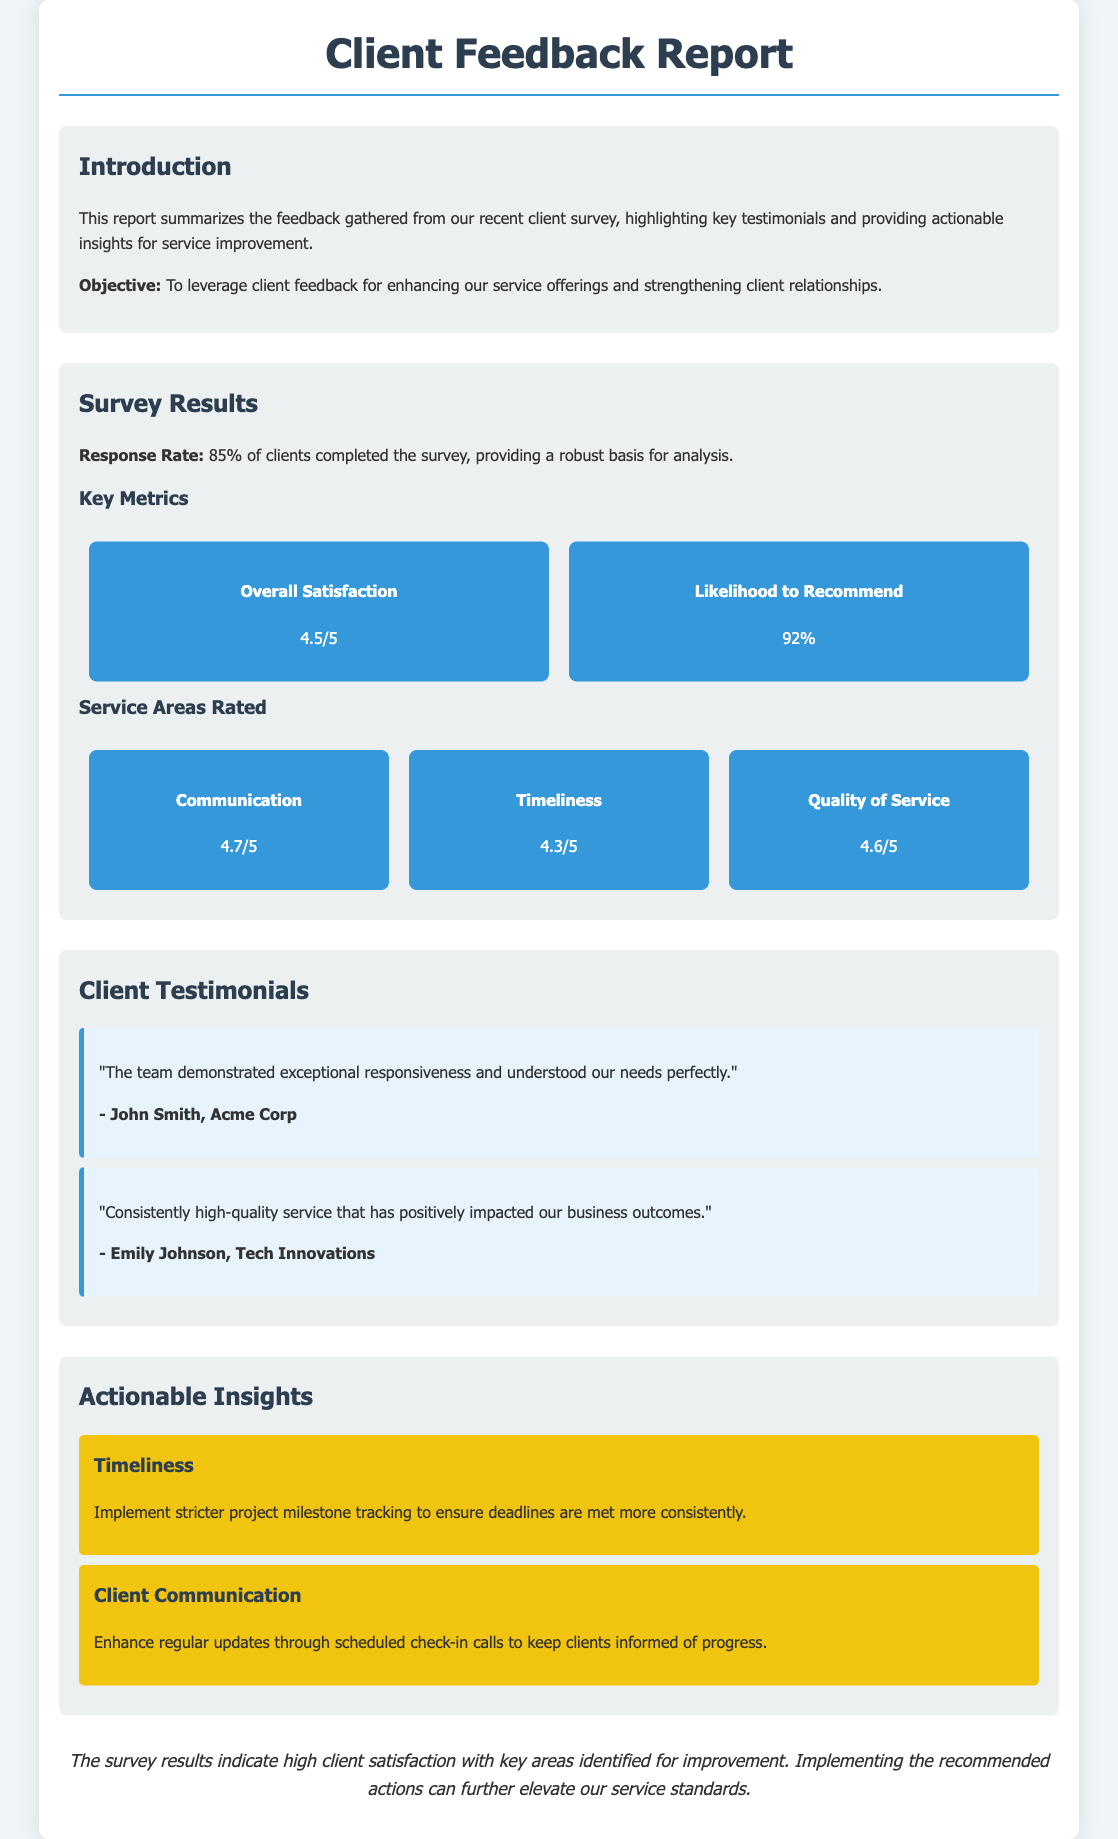what is the response rate of the survey? The response rate of the survey is mentioned as 85% of clients completing it.
Answer: 85% what is the overall satisfaction score? The overall satisfaction score is provided in the metrics section as 4.5 out of 5.
Answer: 4.5/5 who provided the testimonial about exceptional responsiveness? The testimonial regarding exceptional responsiveness is given by John Smith from Acme Corp.
Answer: John Smith, Acme Corp what actionable insight is suggested for timeliness? The document suggests implementing stricter project milestone tracking for timeliness improvement.
Answer: Implement stricter project milestone tracking what is the likelihood to recommend percentage? The likelihood to recommend percentage is reported as 92%.
Answer: 92% how many key metrics are listed under survey results? There are four key metrics listed under survey results.
Answer: Four what is the main objective of the report? The objective of the report is to leverage client feedback for enhancing service offerings.
Answer: Enhance service offerings which service area received a rating of 4.6 out of 5? The service area rated 4.6 out of 5 is quality of service.
Answer: Quality of Service how many testimonials are included in the document? There are two testimonials included in the document.
Answer: Two 